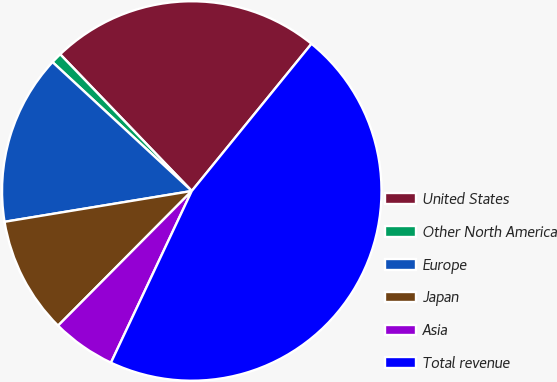Convert chart to OTSL. <chart><loc_0><loc_0><loc_500><loc_500><pie_chart><fcel>United States<fcel>Other North America<fcel>Europe<fcel>Japan<fcel>Asia<fcel>Total revenue<nl><fcel>23.06%<fcel>0.92%<fcel>14.48%<fcel>9.96%<fcel>5.44%<fcel>46.13%<nl></chart> 